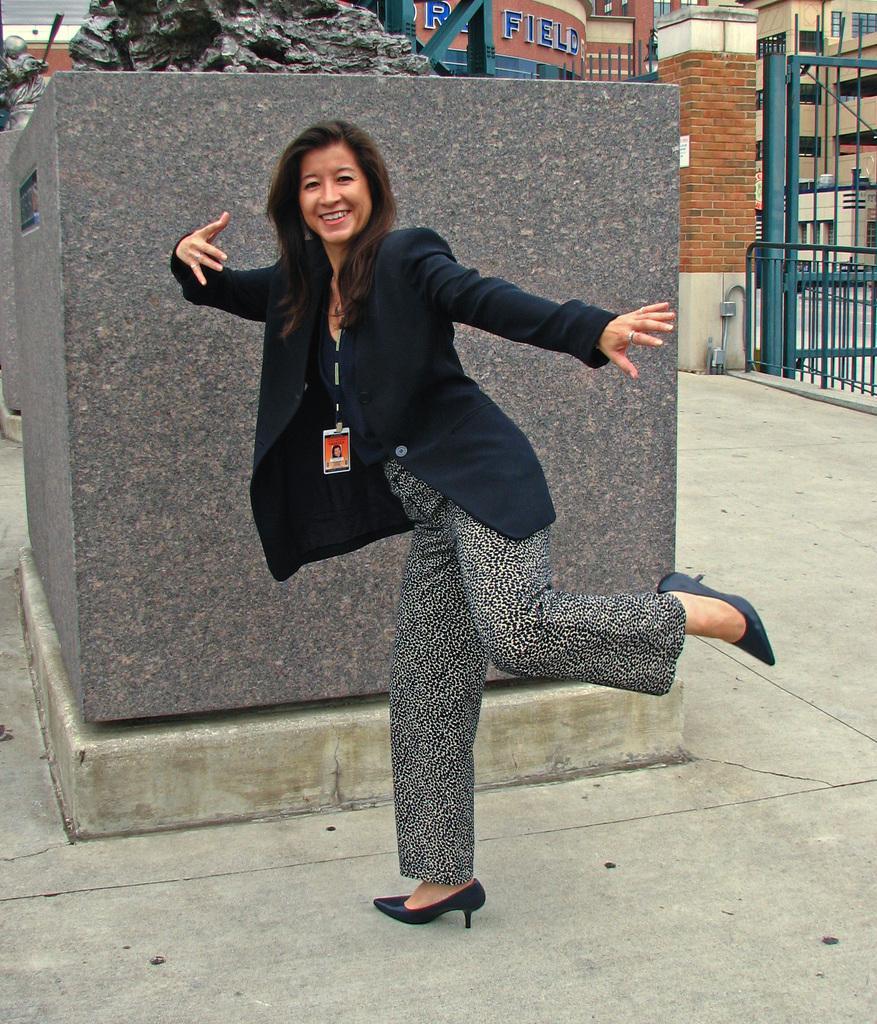How would you summarize this image in a sentence or two? In the center of the image there is a woman standing on the floor. In the background we can see statue, buildings and gate. 